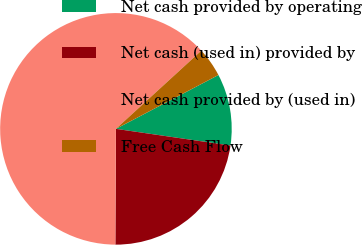Convert chart to OTSL. <chart><loc_0><loc_0><loc_500><loc_500><pie_chart><fcel>Net cash provided by operating<fcel>Net cash (used in) provided by<fcel>Net cash provided by (used in)<fcel>Free Cash Flow<nl><fcel>10.0%<fcel>22.78%<fcel>63.12%<fcel>4.1%<nl></chart> 